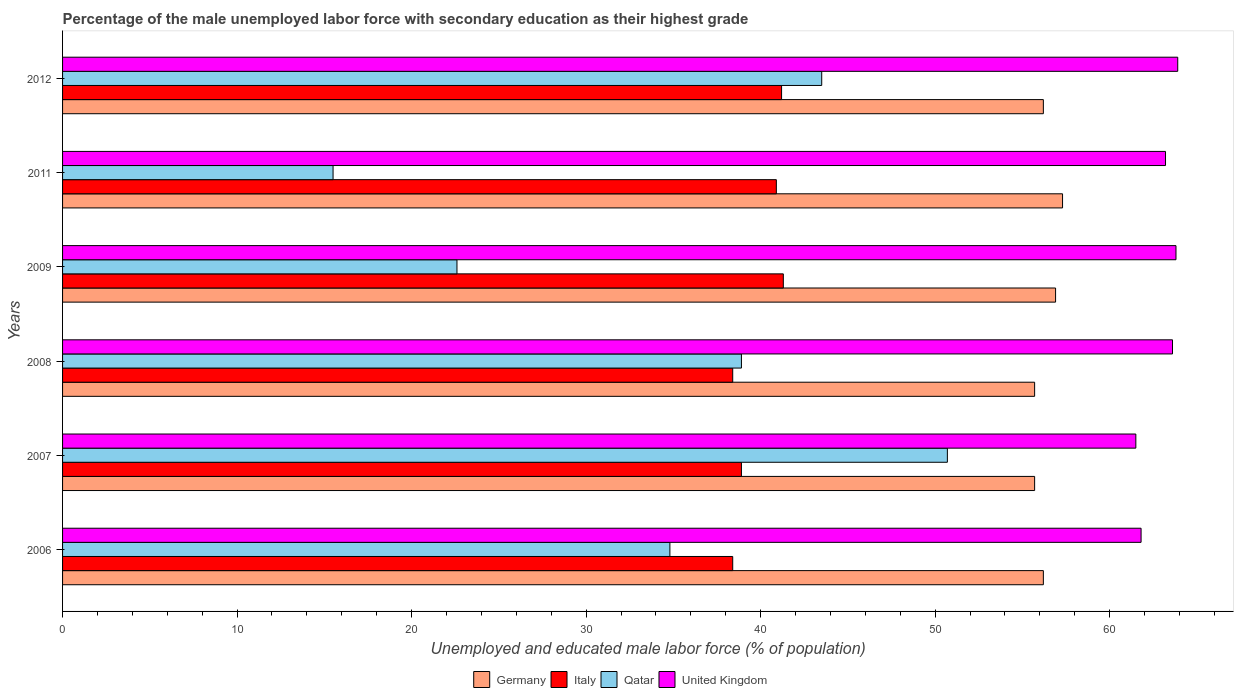How many groups of bars are there?
Provide a succinct answer. 6. Are the number of bars per tick equal to the number of legend labels?
Offer a terse response. Yes. Are the number of bars on each tick of the Y-axis equal?
Ensure brevity in your answer.  Yes. How many bars are there on the 2nd tick from the bottom?
Offer a very short reply. 4. In how many cases, is the number of bars for a given year not equal to the number of legend labels?
Your response must be concise. 0. What is the percentage of the unemployed male labor force with secondary education in Germany in 2008?
Provide a short and direct response. 55.7. Across all years, what is the maximum percentage of the unemployed male labor force with secondary education in United Kingdom?
Offer a very short reply. 63.9. Across all years, what is the minimum percentage of the unemployed male labor force with secondary education in Qatar?
Offer a terse response. 15.5. In which year was the percentage of the unemployed male labor force with secondary education in United Kingdom minimum?
Keep it short and to the point. 2007. What is the total percentage of the unemployed male labor force with secondary education in Qatar in the graph?
Your response must be concise. 206. What is the difference between the percentage of the unemployed male labor force with secondary education in Qatar in 2008 and that in 2009?
Your answer should be very brief. 16.3. What is the difference between the percentage of the unemployed male labor force with secondary education in Italy in 2009 and the percentage of the unemployed male labor force with secondary education in Germany in 2007?
Provide a short and direct response. -14.4. What is the average percentage of the unemployed male labor force with secondary education in United Kingdom per year?
Provide a short and direct response. 62.97. In the year 2012, what is the difference between the percentage of the unemployed male labor force with secondary education in Germany and percentage of the unemployed male labor force with secondary education in United Kingdom?
Provide a succinct answer. -7.7. Is the difference between the percentage of the unemployed male labor force with secondary education in Germany in 2009 and 2012 greater than the difference between the percentage of the unemployed male labor force with secondary education in United Kingdom in 2009 and 2012?
Ensure brevity in your answer.  Yes. What is the difference between the highest and the second highest percentage of the unemployed male labor force with secondary education in Italy?
Offer a very short reply. 0.1. What is the difference between the highest and the lowest percentage of the unemployed male labor force with secondary education in United Kingdom?
Make the answer very short. 2.4. Is it the case that in every year, the sum of the percentage of the unemployed male labor force with secondary education in Germany and percentage of the unemployed male labor force with secondary education in United Kingdom is greater than the sum of percentage of the unemployed male labor force with secondary education in Italy and percentage of the unemployed male labor force with secondary education in Qatar?
Your answer should be compact. No. What does the 3rd bar from the bottom in 2007 represents?
Provide a short and direct response. Qatar. Does the graph contain grids?
Keep it short and to the point. No. What is the title of the graph?
Give a very brief answer. Percentage of the male unemployed labor force with secondary education as their highest grade. Does "Palau" appear as one of the legend labels in the graph?
Your answer should be compact. No. What is the label or title of the X-axis?
Provide a succinct answer. Unemployed and educated male labor force (% of population). What is the label or title of the Y-axis?
Provide a short and direct response. Years. What is the Unemployed and educated male labor force (% of population) of Germany in 2006?
Ensure brevity in your answer.  56.2. What is the Unemployed and educated male labor force (% of population) of Italy in 2006?
Ensure brevity in your answer.  38.4. What is the Unemployed and educated male labor force (% of population) of Qatar in 2006?
Provide a succinct answer. 34.8. What is the Unemployed and educated male labor force (% of population) of United Kingdom in 2006?
Provide a short and direct response. 61.8. What is the Unemployed and educated male labor force (% of population) of Germany in 2007?
Your answer should be very brief. 55.7. What is the Unemployed and educated male labor force (% of population) in Italy in 2007?
Make the answer very short. 38.9. What is the Unemployed and educated male labor force (% of population) of Qatar in 2007?
Make the answer very short. 50.7. What is the Unemployed and educated male labor force (% of population) of United Kingdom in 2007?
Make the answer very short. 61.5. What is the Unemployed and educated male labor force (% of population) of Germany in 2008?
Make the answer very short. 55.7. What is the Unemployed and educated male labor force (% of population) in Italy in 2008?
Your answer should be compact. 38.4. What is the Unemployed and educated male labor force (% of population) in Qatar in 2008?
Your answer should be compact. 38.9. What is the Unemployed and educated male labor force (% of population) in United Kingdom in 2008?
Make the answer very short. 63.6. What is the Unemployed and educated male labor force (% of population) in Germany in 2009?
Provide a short and direct response. 56.9. What is the Unemployed and educated male labor force (% of population) in Italy in 2009?
Provide a short and direct response. 41.3. What is the Unemployed and educated male labor force (% of population) of Qatar in 2009?
Provide a short and direct response. 22.6. What is the Unemployed and educated male labor force (% of population) of United Kingdom in 2009?
Provide a short and direct response. 63.8. What is the Unemployed and educated male labor force (% of population) in Germany in 2011?
Your response must be concise. 57.3. What is the Unemployed and educated male labor force (% of population) of Italy in 2011?
Your answer should be compact. 40.9. What is the Unemployed and educated male labor force (% of population) of United Kingdom in 2011?
Make the answer very short. 63.2. What is the Unemployed and educated male labor force (% of population) in Germany in 2012?
Your answer should be compact. 56.2. What is the Unemployed and educated male labor force (% of population) of Italy in 2012?
Your answer should be very brief. 41.2. What is the Unemployed and educated male labor force (% of population) in Qatar in 2012?
Offer a terse response. 43.5. What is the Unemployed and educated male labor force (% of population) in United Kingdom in 2012?
Ensure brevity in your answer.  63.9. Across all years, what is the maximum Unemployed and educated male labor force (% of population) in Germany?
Offer a terse response. 57.3. Across all years, what is the maximum Unemployed and educated male labor force (% of population) of Italy?
Your answer should be compact. 41.3. Across all years, what is the maximum Unemployed and educated male labor force (% of population) of Qatar?
Give a very brief answer. 50.7. Across all years, what is the maximum Unemployed and educated male labor force (% of population) of United Kingdom?
Offer a very short reply. 63.9. Across all years, what is the minimum Unemployed and educated male labor force (% of population) in Germany?
Give a very brief answer. 55.7. Across all years, what is the minimum Unemployed and educated male labor force (% of population) of Italy?
Your answer should be very brief. 38.4. Across all years, what is the minimum Unemployed and educated male labor force (% of population) in Qatar?
Make the answer very short. 15.5. Across all years, what is the minimum Unemployed and educated male labor force (% of population) of United Kingdom?
Offer a terse response. 61.5. What is the total Unemployed and educated male labor force (% of population) in Germany in the graph?
Your answer should be compact. 338. What is the total Unemployed and educated male labor force (% of population) of Italy in the graph?
Keep it short and to the point. 239.1. What is the total Unemployed and educated male labor force (% of population) of Qatar in the graph?
Your response must be concise. 206. What is the total Unemployed and educated male labor force (% of population) of United Kingdom in the graph?
Offer a very short reply. 377.8. What is the difference between the Unemployed and educated male labor force (% of population) in Germany in 2006 and that in 2007?
Your answer should be very brief. 0.5. What is the difference between the Unemployed and educated male labor force (% of population) of Italy in 2006 and that in 2007?
Offer a very short reply. -0.5. What is the difference between the Unemployed and educated male labor force (% of population) in Qatar in 2006 and that in 2007?
Your response must be concise. -15.9. What is the difference between the Unemployed and educated male labor force (% of population) of United Kingdom in 2006 and that in 2008?
Give a very brief answer. -1.8. What is the difference between the Unemployed and educated male labor force (% of population) of Germany in 2006 and that in 2009?
Provide a succinct answer. -0.7. What is the difference between the Unemployed and educated male labor force (% of population) of Qatar in 2006 and that in 2009?
Offer a terse response. 12.2. What is the difference between the Unemployed and educated male labor force (% of population) of Germany in 2006 and that in 2011?
Give a very brief answer. -1.1. What is the difference between the Unemployed and educated male labor force (% of population) of Qatar in 2006 and that in 2011?
Your response must be concise. 19.3. What is the difference between the Unemployed and educated male labor force (% of population) in United Kingdom in 2006 and that in 2011?
Ensure brevity in your answer.  -1.4. What is the difference between the Unemployed and educated male labor force (% of population) in Italy in 2006 and that in 2012?
Make the answer very short. -2.8. What is the difference between the Unemployed and educated male labor force (% of population) in Qatar in 2006 and that in 2012?
Ensure brevity in your answer.  -8.7. What is the difference between the Unemployed and educated male labor force (% of population) in Germany in 2007 and that in 2008?
Offer a very short reply. 0. What is the difference between the Unemployed and educated male labor force (% of population) in Qatar in 2007 and that in 2008?
Your response must be concise. 11.8. What is the difference between the Unemployed and educated male labor force (% of population) in United Kingdom in 2007 and that in 2008?
Ensure brevity in your answer.  -2.1. What is the difference between the Unemployed and educated male labor force (% of population) of Italy in 2007 and that in 2009?
Offer a very short reply. -2.4. What is the difference between the Unemployed and educated male labor force (% of population) of Qatar in 2007 and that in 2009?
Give a very brief answer. 28.1. What is the difference between the Unemployed and educated male labor force (% of population) of United Kingdom in 2007 and that in 2009?
Ensure brevity in your answer.  -2.3. What is the difference between the Unemployed and educated male labor force (% of population) in Italy in 2007 and that in 2011?
Ensure brevity in your answer.  -2. What is the difference between the Unemployed and educated male labor force (% of population) of Qatar in 2007 and that in 2011?
Offer a terse response. 35.2. What is the difference between the Unemployed and educated male labor force (% of population) of Qatar in 2007 and that in 2012?
Your answer should be very brief. 7.2. What is the difference between the Unemployed and educated male labor force (% of population) in Italy in 2008 and that in 2009?
Offer a very short reply. -2.9. What is the difference between the Unemployed and educated male labor force (% of population) in United Kingdom in 2008 and that in 2009?
Offer a very short reply. -0.2. What is the difference between the Unemployed and educated male labor force (% of population) of Germany in 2008 and that in 2011?
Provide a succinct answer. -1.6. What is the difference between the Unemployed and educated male labor force (% of population) in Italy in 2008 and that in 2011?
Offer a terse response. -2.5. What is the difference between the Unemployed and educated male labor force (% of population) of Qatar in 2008 and that in 2011?
Ensure brevity in your answer.  23.4. What is the difference between the Unemployed and educated male labor force (% of population) in Germany in 2008 and that in 2012?
Give a very brief answer. -0.5. What is the difference between the Unemployed and educated male labor force (% of population) in Qatar in 2008 and that in 2012?
Your answer should be compact. -4.6. What is the difference between the Unemployed and educated male labor force (% of population) of United Kingdom in 2008 and that in 2012?
Offer a very short reply. -0.3. What is the difference between the Unemployed and educated male labor force (% of population) in Germany in 2009 and that in 2011?
Your answer should be very brief. -0.4. What is the difference between the Unemployed and educated male labor force (% of population) in Italy in 2009 and that in 2011?
Your answer should be very brief. 0.4. What is the difference between the Unemployed and educated male labor force (% of population) of Qatar in 2009 and that in 2011?
Keep it short and to the point. 7.1. What is the difference between the Unemployed and educated male labor force (% of population) in United Kingdom in 2009 and that in 2011?
Offer a terse response. 0.6. What is the difference between the Unemployed and educated male labor force (% of population) in Germany in 2009 and that in 2012?
Offer a very short reply. 0.7. What is the difference between the Unemployed and educated male labor force (% of population) of Italy in 2009 and that in 2012?
Keep it short and to the point. 0.1. What is the difference between the Unemployed and educated male labor force (% of population) in Qatar in 2009 and that in 2012?
Ensure brevity in your answer.  -20.9. What is the difference between the Unemployed and educated male labor force (% of population) in United Kingdom in 2009 and that in 2012?
Provide a succinct answer. -0.1. What is the difference between the Unemployed and educated male labor force (% of population) of Germany in 2011 and that in 2012?
Ensure brevity in your answer.  1.1. What is the difference between the Unemployed and educated male labor force (% of population) in United Kingdom in 2011 and that in 2012?
Provide a succinct answer. -0.7. What is the difference between the Unemployed and educated male labor force (% of population) in Germany in 2006 and the Unemployed and educated male labor force (% of population) in Italy in 2007?
Ensure brevity in your answer.  17.3. What is the difference between the Unemployed and educated male labor force (% of population) in Italy in 2006 and the Unemployed and educated male labor force (% of population) in Qatar in 2007?
Keep it short and to the point. -12.3. What is the difference between the Unemployed and educated male labor force (% of population) in Italy in 2006 and the Unemployed and educated male labor force (% of population) in United Kingdom in 2007?
Offer a very short reply. -23.1. What is the difference between the Unemployed and educated male labor force (% of population) of Qatar in 2006 and the Unemployed and educated male labor force (% of population) of United Kingdom in 2007?
Provide a succinct answer. -26.7. What is the difference between the Unemployed and educated male labor force (% of population) in Germany in 2006 and the Unemployed and educated male labor force (% of population) in Italy in 2008?
Your answer should be very brief. 17.8. What is the difference between the Unemployed and educated male labor force (% of population) in Germany in 2006 and the Unemployed and educated male labor force (% of population) in Qatar in 2008?
Keep it short and to the point. 17.3. What is the difference between the Unemployed and educated male labor force (% of population) in Germany in 2006 and the Unemployed and educated male labor force (% of population) in United Kingdom in 2008?
Offer a terse response. -7.4. What is the difference between the Unemployed and educated male labor force (% of population) in Italy in 2006 and the Unemployed and educated male labor force (% of population) in Qatar in 2008?
Your response must be concise. -0.5. What is the difference between the Unemployed and educated male labor force (% of population) in Italy in 2006 and the Unemployed and educated male labor force (% of population) in United Kingdom in 2008?
Give a very brief answer. -25.2. What is the difference between the Unemployed and educated male labor force (% of population) in Qatar in 2006 and the Unemployed and educated male labor force (% of population) in United Kingdom in 2008?
Offer a terse response. -28.8. What is the difference between the Unemployed and educated male labor force (% of population) in Germany in 2006 and the Unemployed and educated male labor force (% of population) in Qatar in 2009?
Keep it short and to the point. 33.6. What is the difference between the Unemployed and educated male labor force (% of population) in Italy in 2006 and the Unemployed and educated male labor force (% of population) in United Kingdom in 2009?
Ensure brevity in your answer.  -25.4. What is the difference between the Unemployed and educated male labor force (% of population) in Qatar in 2006 and the Unemployed and educated male labor force (% of population) in United Kingdom in 2009?
Keep it short and to the point. -29. What is the difference between the Unemployed and educated male labor force (% of population) of Germany in 2006 and the Unemployed and educated male labor force (% of population) of Italy in 2011?
Keep it short and to the point. 15.3. What is the difference between the Unemployed and educated male labor force (% of population) of Germany in 2006 and the Unemployed and educated male labor force (% of population) of Qatar in 2011?
Give a very brief answer. 40.7. What is the difference between the Unemployed and educated male labor force (% of population) of Italy in 2006 and the Unemployed and educated male labor force (% of population) of Qatar in 2011?
Provide a succinct answer. 22.9. What is the difference between the Unemployed and educated male labor force (% of population) of Italy in 2006 and the Unemployed and educated male labor force (% of population) of United Kingdom in 2011?
Give a very brief answer. -24.8. What is the difference between the Unemployed and educated male labor force (% of population) of Qatar in 2006 and the Unemployed and educated male labor force (% of population) of United Kingdom in 2011?
Your answer should be compact. -28.4. What is the difference between the Unemployed and educated male labor force (% of population) in Germany in 2006 and the Unemployed and educated male labor force (% of population) in United Kingdom in 2012?
Offer a terse response. -7.7. What is the difference between the Unemployed and educated male labor force (% of population) of Italy in 2006 and the Unemployed and educated male labor force (% of population) of Qatar in 2012?
Your response must be concise. -5.1. What is the difference between the Unemployed and educated male labor force (% of population) in Italy in 2006 and the Unemployed and educated male labor force (% of population) in United Kingdom in 2012?
Keep it short and to the point. -25.5. What is the difference between the Unemployed and educated male labor force (% of population) of Qatar in 2006 and the Unemployed and educated male labor force (% of population) of United Kingdom in 2012?
Ensure brevity in your answer.  -29.1. What is the difference between the Unemployed and educated male labor force (% of population) in Germany in 2007 and the Unemployed and educated male labor force (% of population) in Italy in 2008?
Ensure brevity in your answer.  17.3. What is the difference between the Unemployed and educated male labor force (% of population) in Germany in 2007 and the Unemployed and educated male labor force (% of population) in Qatar in 2008?
Your response must be concise. 16.8. What is the difference between the Unemployed and educated male labor force (% of population) in Italy in 2007 and the Unemployed and educated male labor force (% of population) in United Kingdom in 2008?
Your answer should be compact. -24.7. What is the difference between the Unemployed and educated male labor force (% of population) in Qatar in 2007 and the Unemployed and educated male labor force (% of population) in United Kingdom in 2008?
Offer a terse response. -12.9. What is the difference between the Unemployed and educated male labor force (% of population) of Germany in 2007 and the Unemployed and educated male labor force (% of population) of Italy in 2009?
Offer a very short reply. 14.4. What is the difference between the Unemployed and educated male labor force (% of population) in Germany in 2007 and the Unemployed and educated male labor force (% of population) in Qatar in 2009?
Your response must be concise. 33.1. What is the difference between the Unemployed and educated male labor force (% of population) in Italy in 2007 and the Unemployed and educated male labor force (% of population) in Qatar in 2009?
Ensure brevity in your answer.  16.3. What is the difference between the Unemployed and educated male labor force (% of population) in Italy in 2007 and the Unemployed and educated male labor force (% of population) in United Kingdom in 2009?
Provide a short and direct response. -24.9. What is the difference between the Unemployed and educated male labor force (% of population) in Qatar in 2007 and the Unemployed and educated male labor force (% of population) in United Kingdom in 2009?
Provide a succinct answer. -13.1. What is the difference between the Unemployed and educated male labor force (% of population) in Germany in 2007 and the Unemployed and educated male labor force (% of population) in Qatar in 2011?
Offer a very short reply. 40.2. What is the difference between the Unemployed and educated male labor force (% of population) in Italy in 2007 and the Unemployed and educated male labor force (% of population) in Qatar in 2011?
Make the answer very short. 23.4. What is the difference between the Unemployed and educated male labor force (% of population) in Italy in 2007 and the Unemployed and educated male labor force (% of population) in United Kingdom in 2011?
Your answer should be compact. -24.3. What is the difference between the Unemployed and educated male labor force (% of population) in Qatar in 2007 and the Unemployed and educated male labor force (% of population) in United Kingdom in 2011?
Make the answer very short. -12.5. What is the difference between the Unemployed and educated male labor force (% of population) of Germany in 2007 and the Unemployed and educated male labor force (% of population) of Italy in 2012?
Ensure brevity in your answer.  14.5. What is the difference between the Unemployed and educated male labor force (% of population) of Germany in 2007 and the Unemployed and educated male labor force (% of population) of Qatar in 2012?
Keep it short and to the point. 12.2. What is the difference between the Unemployed and educated male labor force (% of population) in Germany in 2007 and the Unemployed and educated male labor force (% of population) in United Kingdom in 2012?
Keep it short and to the point. -8.2. What is the difference between the Unemployed and educated male labor force (% of population) in Italy in 2007 and the Unemployed and educated male labor force (% of population) in Qatar in 2012?
Provide a short and direct response. -4.6. What is the difference between the Unemployed and educated male labor force (% of population) in Qatar in 2007 and the Unemployed and educated male labor force (% of population) in United Kingdom in 2012?
Offer a terse response. -13.2. What is the difference between the Unemployed and educated male labor force (% of population) in Germany in 2008 and the Unemployed and educated male labor force (% of population) in Qatar in 2009?
Your answer should be compact. 33.1. What is the difference between the Unemployed and educated male labor force (% of population) of Germany in 2008 and the Unemployed and educated male labor force (% of population) of United Kingdom in 2009?
Your response must be concise. -8.1. What is the difference between the Unemployed and educated male labor force (% of population) of Italy in 2008 and the Unemployed and educated male labor force (% of population) of Qatar in 2009?
Give a very brief answer. 15.8. What is the difference between the Unemployed and educated male labor force (% of population) in Italy in 2008 and the Unemployed and educated male labor force (% of population) in United Kingdom in 2009?
Your response must be concise. -25.4. What is the difference between the Unemployed and educated male labor force (% of population) in Qatar in 2008 and the Unemployed and educated male labor force (% of population) in United Kingdom in 2009?
Your response must be concise. -24.9. What is the difference between the Unemployed and educated male labor force (% of population) in Germany in 2008 and the Unemployed and educated male labor force (% of population) in Qatar in 2011?
Give a very brief answer. 40.2. What is the difference between the Unemployed and educated male labor force (% of population) of Germany in 2008 and the Unemployed and educated male labor force (% of population) of United Kingdom in 2011?
Provide a short and direct response. -7.5. What is the difference between the Unemployed and educated male labor force (% of population) of Italy in 2008 and the Unemployed and educated male labor force (% of population) of Qatar in 2011?
Make the answer very short. 22.9. What is the difference between the Unemployed and educated male labor force (% of population) in Italy in 2008 and the Unemployed and educated male labor force (% of population) in United Kingdom in 2011?
Provide a succinct answer. -24.8. What is the difference between the Unemployed and educated male labor force (% of population) of Qatar in 2008 and the Unemployed and educated male labor force (% of population) of United Kingdom in 2011?
Your response must be concise. -24.3. What is the difference between the Unemployed and educated male labor force (% of population) of Italy in 2008 and the Unemployed and educated male labor force (% of population) of Qatar in 2012?
Your answer should be very brief. -5.1. What is the difference between the Unemployed and educated male labor force (% of population) in Italy in 2008 and the Unemployed and educated male labor force (% of population) in United Kingdom in 2012?
Your answer should be compact. -25.5. What is the difference between the Unemployed and educated male labor force (% of population) in Qatar in 2008 and the Unemployed and educated male labor force (% of population) in United Kingdom in 2012?
Offer a terse response. -25. What is the difference between the Unemployed and educated male labor force (% of population) of Germany in 2009 and the Unemployed and educated male labor force (% of population) of Qatar in 2011?
Offer a terse response. 41.4. What is the difference between the Unemployed and educated male labor force (% of population) of Italy in 2009 and the Unemployed and educated male labor force (% of population) of Qatar in 2011?
Your answer should be very brief. 25.8. What is the difference between the Unemployed and educated male labor force (% of population) in Italy in 2009 and the Unemployed and educated male labor force (% of population) in United Kingdom in 2011?
Give a very brief answer. -21.9. What is the difference between the Unemployed and educated male labor force (% of population) in Qatar in 2009 and the Unemployed and educated male labor force (% of population) in United Kingdom in 2011?
Make the answer very short. -40.6. What is the difference between the Unemployed and educated male labor force (% of population) in Germany in 2009 and the Unemployed and educated male labor force (% of population) in Italy in 2012?
Give a very brief answer. 15.7. What is the difference between the Unemployed and educated male labor force (% of population) in Germany in 2009 and the Unemployed and educated male labor force (% of population) in United Kingdom in 2012?
Provide a short and direct response. -7. What is the difference between the Unemployed and educated male labor force (% of population) of Italy in 2009 and the Unemployed and educated male labor force (% of population) of Qatar in 2012?
Make the answer very short. -2.2. What is the difference between the Unemployed and educated male labor force (% of population) in Italy in 2009 and the Unemployed and educated male labor force (% of population) in United Kingdom in 2012?
Keep it short and to the point. -22.6. What is the difference between the Unemployed and educated male labor force (% of population) in Qatar in 2009 and the Unemployed and educated male labor force (% of population) in United Kingdom in 2012?
Ensure brevity in your answer.  -41.3. What is the difference between the Unemployed and educated male labor force (% of population) in Germany in 2011 and the Unemployed and educated male labor force (% of population) in Qatar in 2012?
Give a very brief answer. 13.8. What is the difference between the Unemployed and educated male labor force (% of population) in Germany in 2011 and the Unemployed and educated male labor force (% of population) in United Kingdom in 2012?
Keep it short and to the point. -6.6. What is the difference between the Unemployed and educated male labor force (% of population) in Italy in 2011 and the Unemployed and educated male labor force (% of population) in Qatar in 2012?
Provide a succinct answer. -2.6. What is the difference between the Unemployed and educated male labor force (% of population) of Italy in 2011 and the Unemployed and educated male labor force (% of population) of United Kingdom in 2012?
Ensure brevity in your answer.  -23. What is the difference between the Unemployed and educated male labor force (% of population) in Qatar in 2011 and the Unemployed and educated male labor force (% of population) in United Kingdom in 2012?
Your answer should be very brief. -48.4. What is the average Unemployed and educated male labor force (% of population) in Germany per year?
Your answer should be very brief. 56.33. What is the average Unemployed and educated male labor force (% of population) in Italy per year?
Your answer should be very brief. 39.85. What is the average Unemployed and educated male labor force (% of population) in Qatar per year?
Ensure brevity in your answer.  34.33. What is the average Unemployed and educated male labor force (% of population) in United Kingdom per year?
Keep it short and to the point. 62.97. In the year 2006, what is the difference between the Unemployed and educated male labor force (% of population) in Germany and Unemployed and educated male labor force (% of population) in Qatar?
Your response must be concise. 21.4. In the year 2006, what is the difference between the Unemployed and educated male labor force (% of population) of Italy and Unemployed and educated male labor force (% of population) of United Kingdom?
Your answer should be very brief. -23.4. In the year 2007, what is the difference between the Unemployed and educated male labor force (% of population) of Italy and Unemployed and educated male labor force (% of population) of Qatar?
Ensure brevity in your answer.  -11.8. In the year 2007, what is the difference between the Unemployed and educated male labor force (% of population) in Italy and Unemployed and educated male labor force (% of population) in United Kingdom?
Make the answer very short. -22.6. In the year 2007, what is the difference between the Unemployed and educated male labor force (% of population) of Qatar and Unemployed and educated male labor force (% of population) of United Kingdom?
Your response must be concise. -10.8. In the year 2008, what is the difference between the Unemployed and educated male labor force (% of population) in Italy and Unemployed and educated male labor force (% of population) in United Kingdom?
Your answer should be very brief. -25.2. In the year 2008, what is the difference between the Unemployed and educated male labor force (% of population) in Qatar and Unemployed and educated male labor force (% of population) in United Kingdom?
Offer a very short reply. -24.7. In the year 2009, what is the difference between the Unemployed and educated male labor force (% of population) in Germany and Unemployed and educated male labor force (% of population) in Italy?
Provide a short and direct response. 15.6. In the year 2009, what is the difference between the Unemployed and educated male labor force (% of population) in Germany and Unemployed and educated male labor force (% of population) in Qatar?
Offer a terse response. 34.3. In the year 2009, what is the difference between the Unemployed and educated male labor force (% of population) in Italy and Unemployed and educated male labor force (% of population) in Qatar?
Provide a succinct answer. 18.7. In the year 2009, what is the difference between the Unemployed and educated male labor force (% of population) in Italy and Unemployed and educated male labor force (% of population) in United Kingdom?
Your answer should be very brief. -22.5. In the year 2009, what is the difference between the Unemployed and educated male labor force (% of population) of Qatar and Unemployed and educated male labor force (% of population) of United Kingdom?
Provide a short and direct response. -41.2. In the year 2011, what is the difference between the Unemployed and educated male labor force (% of population) in Germany and Unemployed and educated male labor force (% of population) in Qatar?
Your response must be concise. 41.8. In the year 2011, what is the difference between the Unemployed and educated male labor force (% of population) of Italy and Unemployed and educated male labor force (% of population) of Qatar?
Offer a very short reply. 25.4. In the year 2011, what is the difference between the Unemployed and educated male labor force (% of population) of Italy and Unemployed and educated male labor force (% of population) of United Kingdom?
Your response must be concise. -22.3. In the year 2011, what is the difference between the Unemployed and educated male labor force (% of population) in Qatar and Unemployed and educated male labor force (% of population) in United Kingdom?
Make the answer very short. -47.7. In the year 2012, what is the difference between the Unemployed and educated male labor force (% of population) of Germany and Unemployed and educated male labor force (% of population) of Qatar?
Offer a terse response. 12.7. In the year 2012, what is the difference between the Unemployed and educated male labor force (% of population) in Germany and Unemployed and educated male labor force (% of population) in United Kingdom?
Offer a terse response. -7.7. In the year 2012, what is the difference between the Unemployed and educated male labor force (% of population) in Italy and Unemployed and educated male labor force (% of population) in United Kingdom?
Give a very brief answer. -22.7. In the year 2012, what is the difference between the Unemployed and educated male labor force (% of population) of Qatar and Unemployed and educated male labor force (% of population) of United Kingdom?
Your response must be concise. -20.4. What is the ratio of the Unemployed and educated male labor force (% of population) of Germany in 2006 to that in 2007?
Your response must be concise. 1.01. What is the ratio of the Unemployed and educated male labor force (% of population) in Italy in 2006 to that in 2007?
Your answer should be very brief. 0.99. What is the ratio of the Unemployed and educated male labor force (% of population) in Qatar in 2006 to that in 2007?
Your answer should be compact. 0.69. What is the ratio of the Unemployed and educated male labor force (% of population) in Qatar in 2006 to that in 2008?
Provide a succinct answer. 0.89. What is the ratio of the Unemployed and educated male labor force (% of population) in United Kingdom in 2006 to that in 2008?
Your response must be concise. 0.97. What is the ratio of the Unemployed and educated male labor force (% of population) of Germany in 2006 to that in 2009?
Give a very brief answer. 0.99. What is the ratio of the Unemployed and educated male labor force (% of population) of Italy in 2006 to that in 2009?
Ensure brevity in your answer.  0.93. What is the ratio of the Unemployed and educated male labor force (% of population) in Qatar in 2006 to that in 2009?
Give a very brief answer. 1.54. What is the ratio of the Unemployed and educated male labor force (% of population) of United Kingdom in 2006 to that in 2009?
Offer a terse response. 0.97. What is the ratio of the Unemployed and educated male labor force (% of population) in Germany in 2006 to that in 2011?
Your answer should be compact. 0.98. What is the ratio of the Unemployed and educated male labor force (% of population) in Italy in 2006 to that in 2011?
Make the answer very short. 0.94. What is the ratio of the Unemployed and educated male labor force (% of population) of Qatar in 2006 to that in 2011?
Your answer should be compact. 2.25. What is the ratio of the Unemployed and educated male labor force (% of population) in United Kingdom in 2006 to that in 2011?
Ensure brevity in your answer.  0.98. What is the ratio of the Unemployed and educated male labor force (% of population) of Germany in 2006 to that in 2012?
Ensure brevity in your answer.  1. What is the ratio of the Unemployed and educated male labor force (% of population) of Italy in 2006 to that in 2012?
Your answer should be compact. 0.93. What is the ratio of the Unemployed and educated male labor force (% of population) of United Kingdom in 2006 to that in 2012?
Give a very brief answer. 0.97. What is the ratio of the Unemployed and educated male labor force (% of population) of Germany in 2007 to that in 2008?
Make the answer very short. 1. What is the ratio of the Unemployed and educated male labor force (% of population) in Qatar in 2007 to that in 2008?
Offer a terse response. 1.3. What is the ratio of the Unemployed and educated male labor force (% of population) in United Kingdom in 2007 to that in 2008?
Your response must be concise. 0.97. What is the ratio of the Unemployed and educated male labor force (% of population) in Germany in 2007 to that in 2009?
Keep it short and to the point. 0.98. What is the ratio of the Unemployed and educated male labor force (% of population) of Italy in 2007 to that in 2009?
Give a very brief answer. 0.94. What is the ratio of the Unemployed and educated male labor force (% of population) of Qatar in 2007 to that in 2009?
Offer a very short reply. 2.24. What is the ratio of the Unemployed and educated male labor force (% of population) in United Kingdom in 2007 to that in 2009?
Your answer should be very brief. 0.96. What is the ratio of the Unemployed and educated male labor force (% of population) in Germany in 2007 to that in 2011?
Offer a terse response. 0.97. What is the ratio of the Unemployed and educated male labor force (% of population) in Italy in 2007 to that in 2011?
Your answer should be very brief. 0.95. What is the ratio of the Unemployed and educated male labor force (% of population) of Qatar in 2007 to that in 2011?
Your response must be concise. 3.27. What is the ratio of the Unemployed and educated male labor force (% of population) in United Kingdom in 2007 to that in 2011?
Your answer should be very brief. 0.97. What is the ratio of the Unemployed and educated male labor force (% of population) in Germany in 2007 to that in 2012?
Give a very brief answer. 0.99. What is the ratio of the Unemployed and educated male labor force (% of population) in Italy in 2007 to that in 2012?
Make the answer very short. 0.94. What is the ratio of the Unemployed and educated male labor force (% of population) of Qatar in 2007 to that in 2012?
Offer a very short reply. 1.17. What is the ratio of the Unemployed and educated male labor force (% of population) of United Kingdom in 2007 to that in 2012?
Offer a terse response. 0.96. What is the ratio of the Unemployed and educated male labor force (% of population) of Germany in 2008 to that in 2009?
Ensure brevity in your answer.  0.98. What is the ratio of the Unemployed and educated male labor force (% of population) in Italy in 2008 to that in 2009?
Your answer should be very brief. 0.93. What is the ratio of the Unemployed and educated male labor force (% of population) of Qatar in 2008 to that in 2009?
Offer a very short reply. 1.72. What is the ratio of the Unemployed and educated male labor force (% of population) in United Kingdom in 2008 to that in 2009?
Provide a short and direct response. 1. What is the ratio of the Unemployed and educated male labor force (% of population) in Germany in 2008 to that in 2011?
Your answer should be very brief. 0.97. What is the ratio of the Unemployed and educated male labor force (% of population) of Italy in 2008 to that in 2011?
Offer a terse response. 0.94. What is the ratio of the Unemployed and educated male labor force (% of population) in Qatar in 2008 to that in 2011?
Ensure brevity in your answer.  2.51. What is the ratio of the Unemployed and educated male labor force (% of population) in Italy in 2008 to that in 2012?
Your answer should be compact. 0.93. What is the ratio of the Unemployed and educated male labor force (% of population) of Qatar in 2008 to that in 2012?
Your answer should be compact. 0.89. What is the ratio of the Unemployed and educated male labor force (% of population) in Germany in 2009 to that in 2011?
Offer a very short reply. 0.99. What is the ratio of the Unemployed and educated male labor force (% of population) of Italy in 2009 to that in 2011?
Your response must be concise. 1.01. What is the ratio of the Unemployed and educated male labor force (% of population) in Qatar in 2009 to that in 2011?
Your answer should be compact. 1.46. What is the ratio of the Unemployed and educated male labor force (% of population) in United Kingdom in 2009 to that in 2011?
Your response must be concise. 1.01. What is the ratio of the Unemployed and educated male labor force (% of population) in Germany in 2009 to that in 2012?
Provide a succinct answer. 1.01. What is the ratio of the Unemployed and educated male labor force (% of population) in Qatar in 2009 to that in 2012?
Your answer should be very brief. 0.52. What is the ratio of the Unemployed and educated male labor force (% of population) of Germany in 2011 to that in 2012?
Offer a terse response. 1.02. What is the ratio of the Unemployed and educated male labor force (% of population) of Italy in 2011 to that in 2012?
Make the answer very short. 0.99. What is the ratio of the Unemployed and educated male labor force (% of population) of Qatar in 2011 to that in 2012?
Keep it short and to the point. 0.36. What is the difference between the highest and the second highest Unemployed and educated male labor force (% of population) in Germany?
Offer a terse response. 0.4. What is the difference between the highest and the second highest Unemployed and educated male labor force (% of population) of Qatar?
Give a very brief answer. 7.2. What is the difference between the highest and the lowest Unemployed and educated male labor force (% of population) in Italy?
Offer a terse response. 2.9. What is the difference between the highest and the lowest Unemployed and educated male labor force (% of population) in Qatar?
Keep it short and to the point. 35.2. What is the difference between the highest and the lowest Unemployed and educated male labor force (% of population) in United Kingdom?
Your response must be concise. 2.4. 